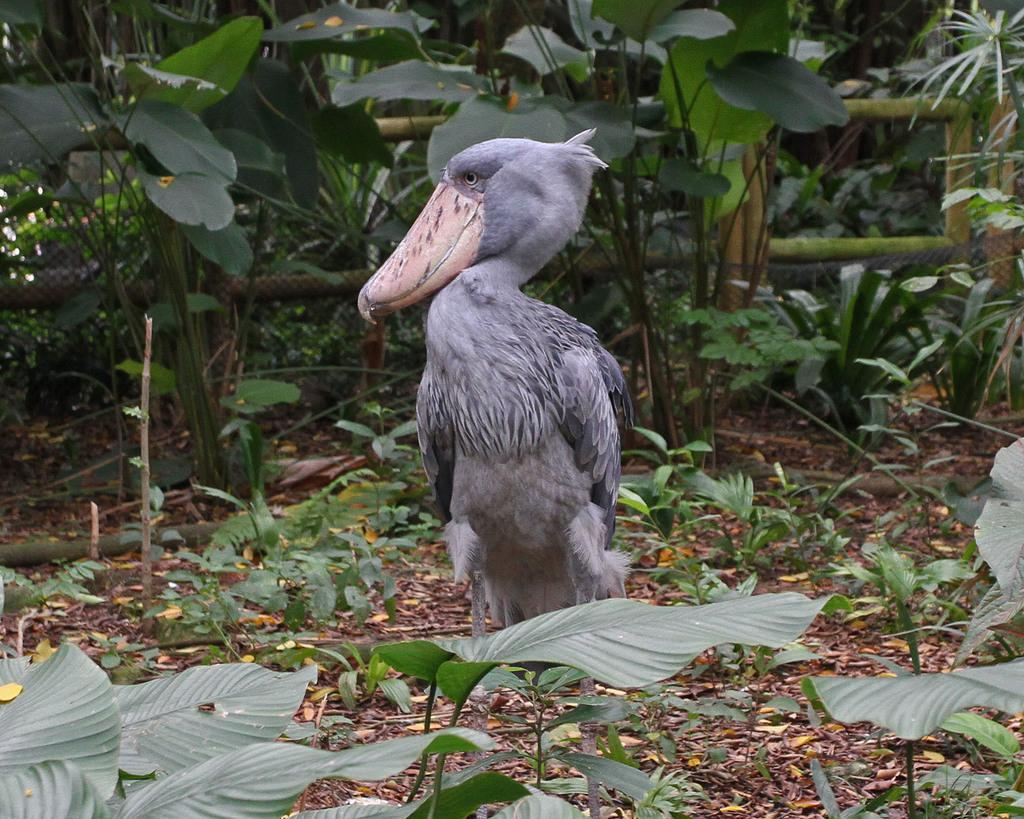What type of animal is present in the image? There is a bird in the image. What other elements can be seen in the image? There are plants and mesh visible in the image. What type of protest is the bird leading in the image? There is no protest present in the image; it features a bird, plants, and mesh. Is the bird's aunt attending the party in the image? There is no party or any reference to an aunt in the image. 